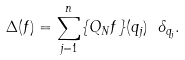<formula> <loc_0><loc_0><loc_500><loc_500>\Delta ( f ) = \sum _ { j = 1 } ^ { n } \{ Q _ { N } f \} ( q _ { j } ) \ \delta _ { q _ { j } } .</formula> 